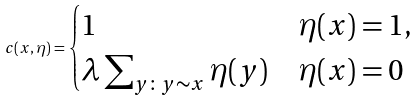<formula> <loc_0><loc_0><loc_500><loc_500>c ( x , \eta ) = \begin{cases} 1 & \eta ( x ) = 1 , \\ \lambda \sum _ { y \colon y \sim x } \eta ( y ) & \eta ( x ) = 0 \end{cases}</formula> 